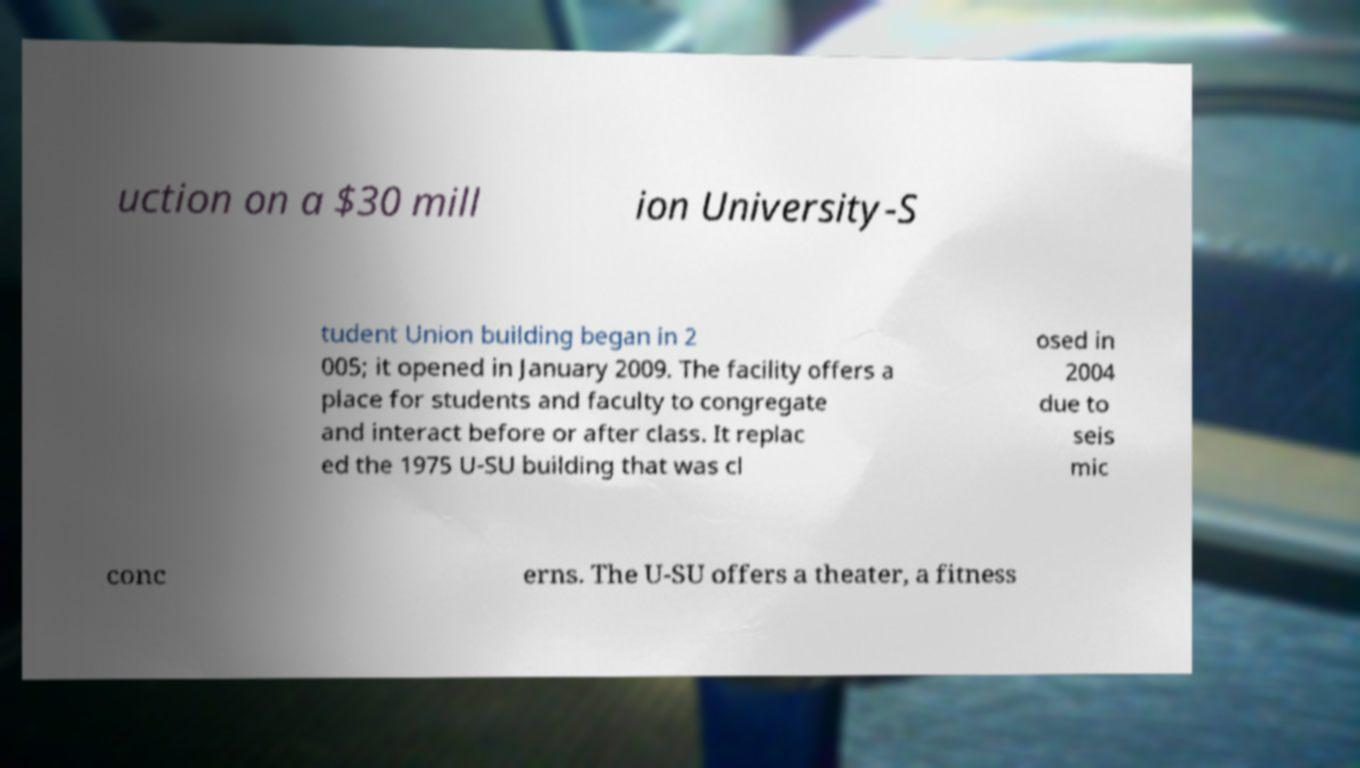Can you read and provide the text displayed in the image?This photo seems to have some interesting text. Can you extract and type it out for me? uction on a $30 mill ion University-S tudent Union building began in 2 005; it opened in January 2009. The facility offers a place for students and faculty to congregate and interact before or after class. It replac ed the 1975 U-SU building that was cl osed in 2004 due to seis mic conc erns. The U-SU offers a theater, a fitness 